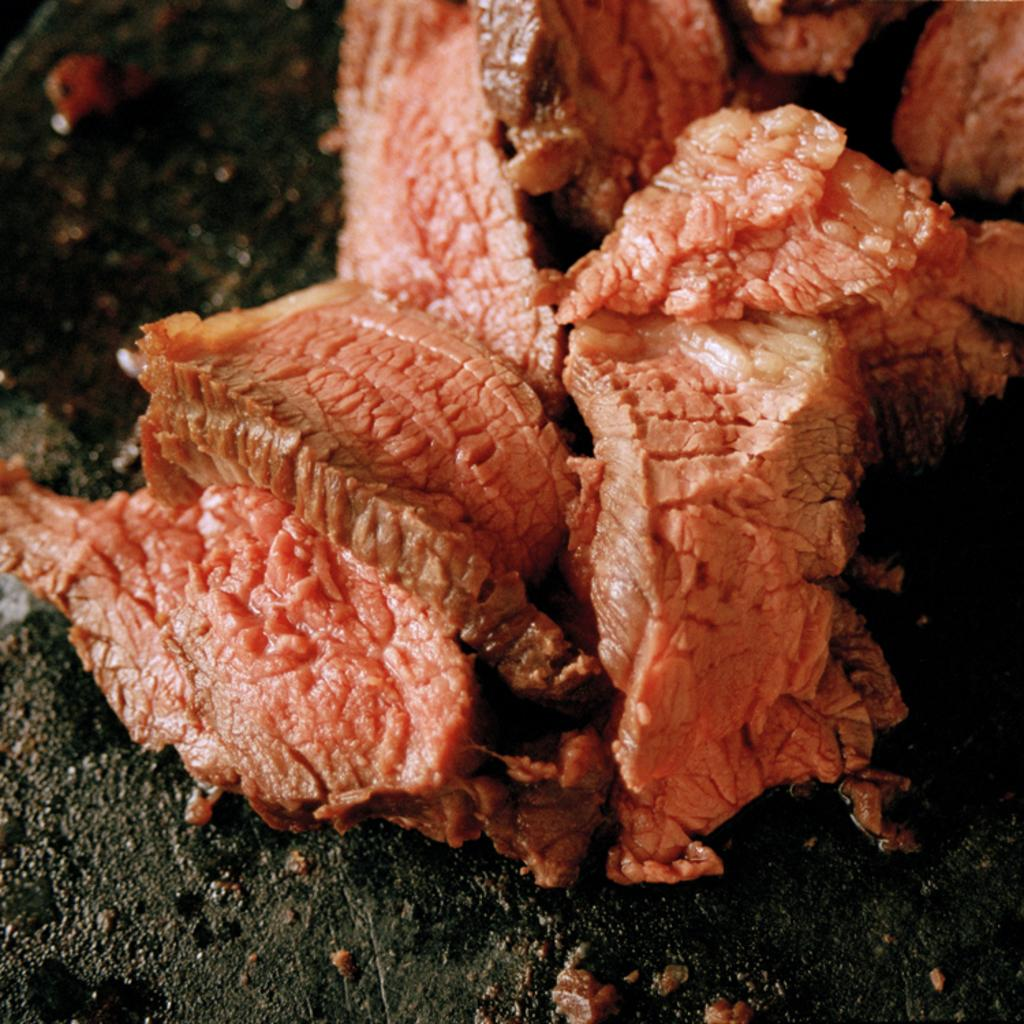What type of material is present in the image? There is flesh in the image. What color is the flesh in the image? The flesh is in red color. Where is the flesh located in the image? The flesh is on the ground. What type of pump can be seen in the image? There is no pump present in the image; it only features flesh in red color on the ground. 